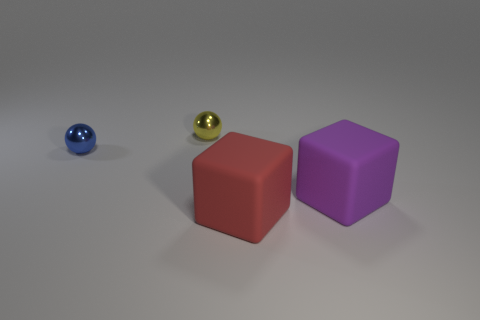Can you describe the lighting of this scene? The lighting in the image suggests an indoor setting with diffused, soft illumination coming from above. Shadows are gentle and cast directly beneath the objects, which indicates a light source positioned overhead, potentially a single diffused light like a softbox or an LED panel that might be used in a photography studio. 